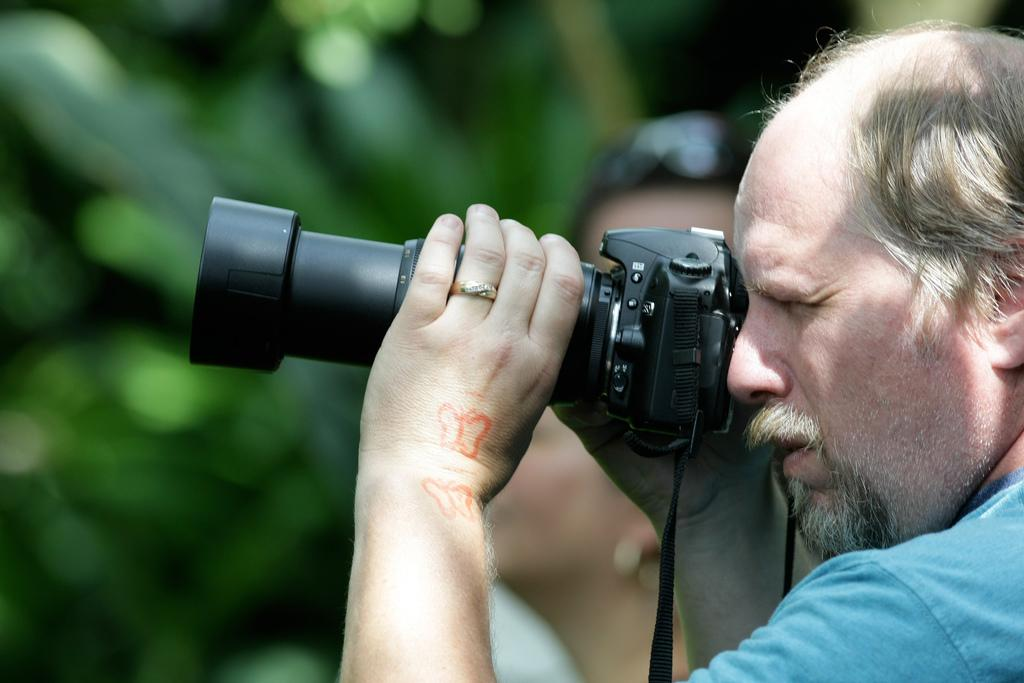What is the main subject of the image? There is a man in the image. What is the man holding in his hands? The man is holding a camera in his hands. What might the man be doing with the camera? The man appears to be capturing a photo. What type of oil can be seen dripping from the camera in the image? There is no oil present in the image, and the camera does not appear to be dripping anything. 